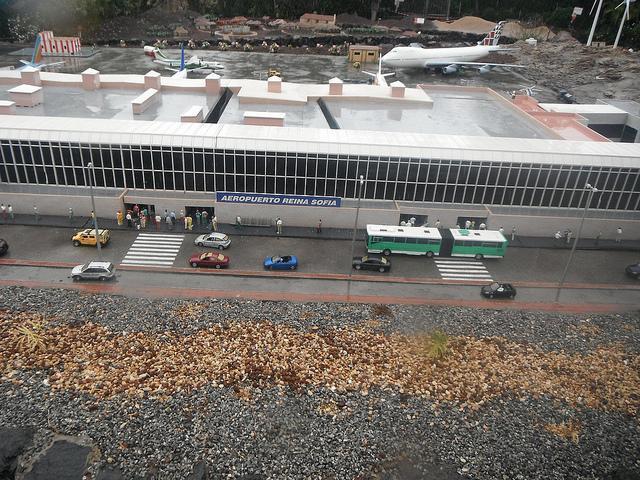How many buses are there?
Give a very brief answer. 1. How many chairs are behind the pole?
Give a very brief answer. 0. 